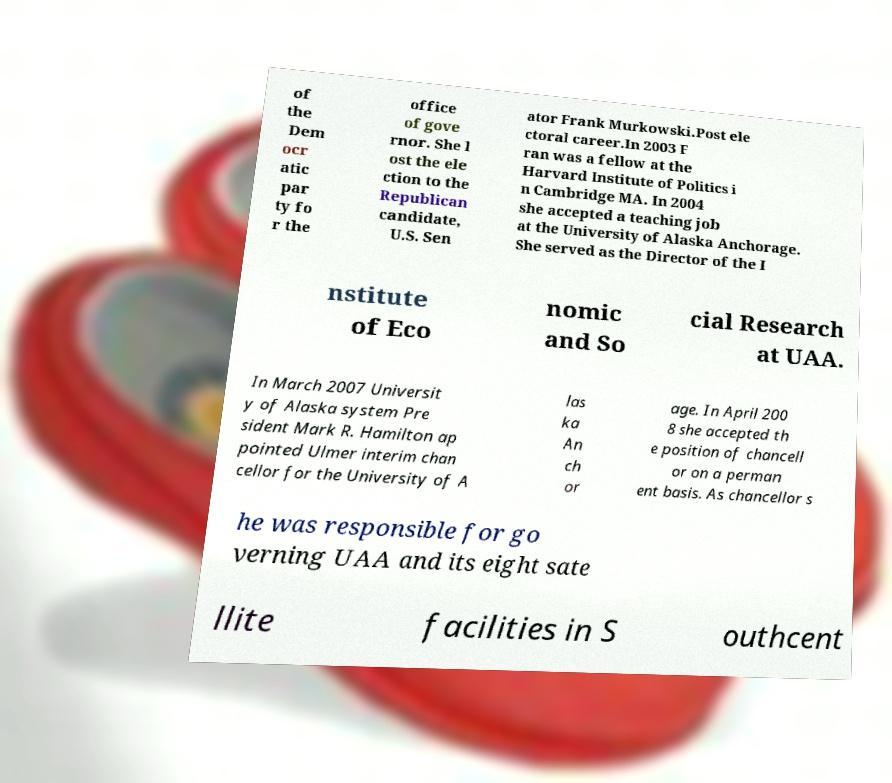For documentation purposes, I need the text within this image transcribed. Could you provide that? of the Dem ocr atic par ty fo r the office of gove rnor. She l ost the ele ction to the Republican candidate, U.S. Sen ator Frank Murkowski.Post ele ctoral career.In 2003 F ran was a fellow at the Harvard Institute of Politics i n Cambridge MA. In 2004 she accepted a teaching job at the University of Alaska Anchorage. She served as the Director of the I nstitute of Eco nomic and So cial Research at UAA. In March 2007 Universit y of Alaska system Pre sident Mark R. Hamilton ap pointed Ulmer interim chan cellor for the University of A las ka An ch or age. In April 200 8 she accepted th e position of chancell or on a perman ent basis. As chancellor s he was responsible for go verning UAA and its eight sate llite facilities in S outhcent 